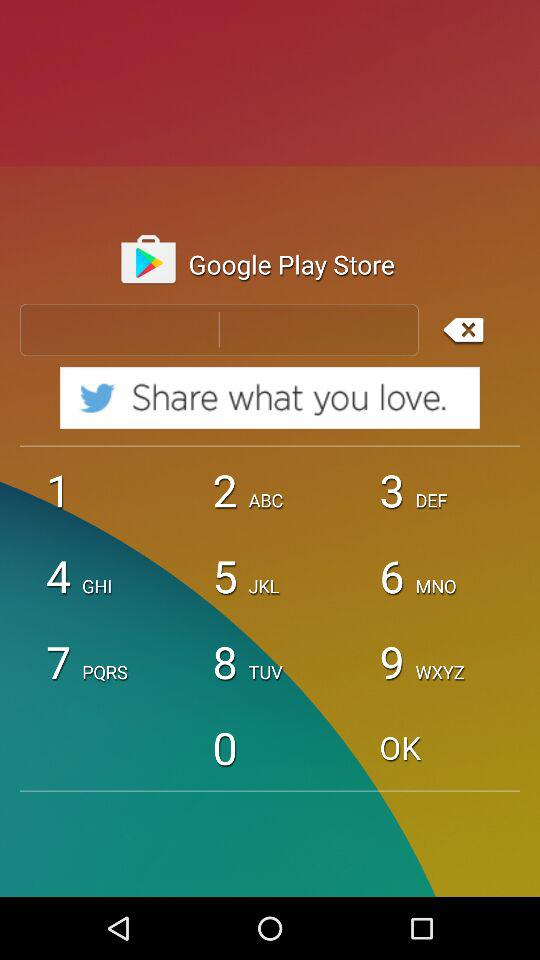What is the application name? The application name is "Total Fitness". 